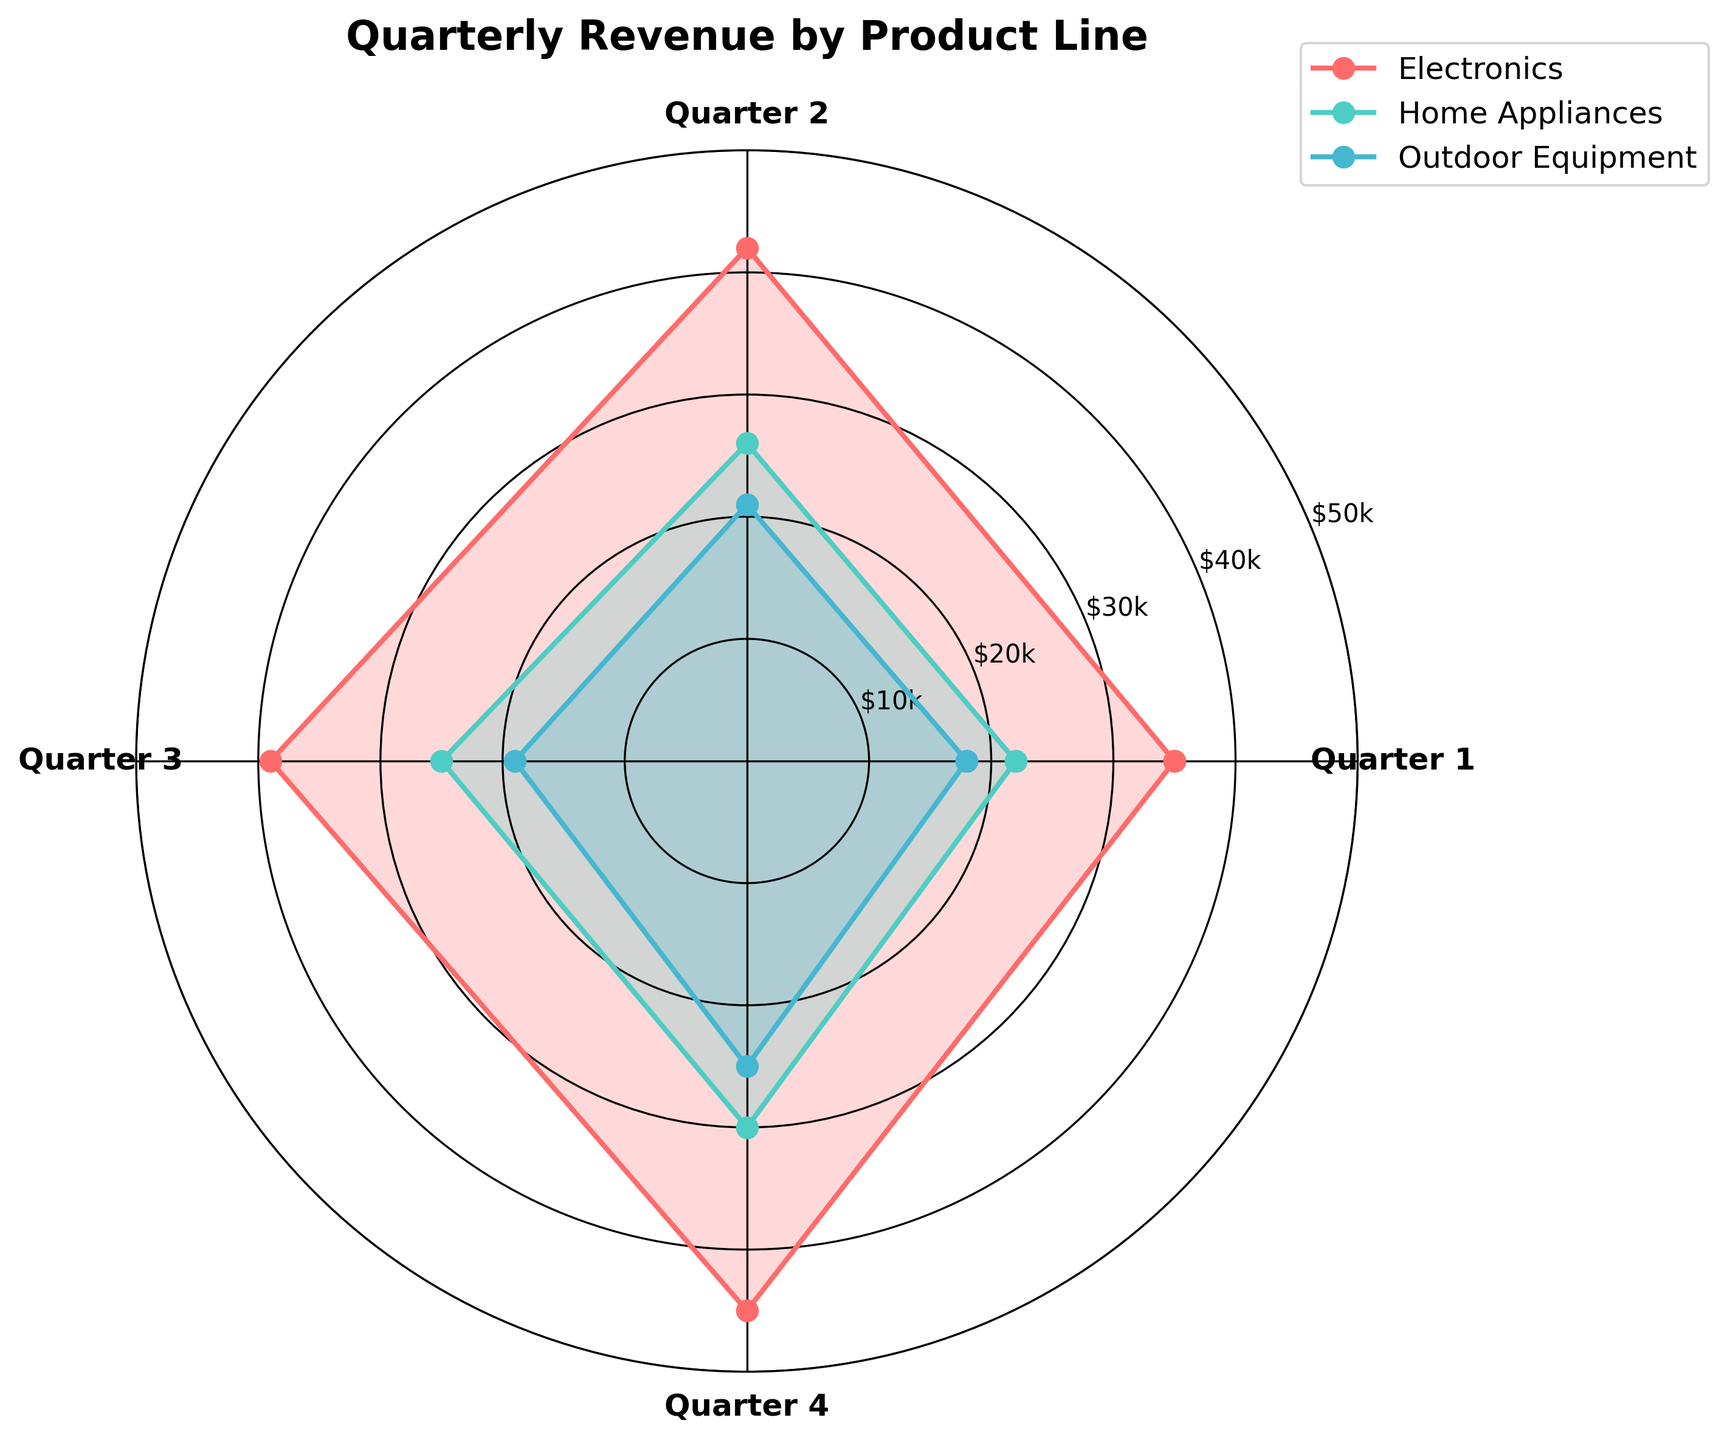What is the title of the chart? The title is displayed at the top of the chart.
Answer: Quarterly Revenue by Product Line Which product line has the highest revenue in Quarter 4? Look at the plot lines and areas filled in for Quarter 4 and identify the highest. Electronics has the highest fill and peak in Quarter 4.
Answer: Electronics What is the overall trend in revenue for Home Appliances over the four quarters? Observe the filled area and plot line for the Home Appliances product line. The filled area gradually increases, indicating an upward trend.
Answer: Increasing How much revenue did the Outdoor Equipment category generate in Quarter 1? Locate the segment of the rose chart for Quarter 1. The radius for Outdoor Equipment corresponds to the revenue, which is $18,000.
Answer: $18,000 Does any product line surpass $40,000 in any quarter? Identify segments in the chart with radius extending beyond $40,000. The Electronics line surpasses $40,000 in both Quarter 2 and Quarter 4.
Answer: Yes Which quarter shows the least revenue for Electronics? Compare the filled areas and plot points of the Electronics line across quarters. Quarters 2 has a smaller radius compared to other quarters.
Answer: Quarter 1 Calculate the average quarterly revenue for Home Appliances. Sum of Home Appliances revenues across four quarters is $22,000 + $26,000 + $25,000 + $30,000 = $103,000. The average is $103,000 / 4 = $25,750.
Answer: $25,750 Compare the revenue difference between Electronics and Outdoor Equipment in Quarter 3. Revenue for Electronics in Quarter 3 is $39,000 and for Outdoor Equipment is $19,000. The difference is $39,000 - $19,000 = $20,000.
Answer: $20,000 Which product line exhibits the most consistent revenue across all quarters? Look at the consistency in the areas and plot lines. Home Appliances shows a steady and small increase across all quarters compared to fluctuations in Electronics and Outdoor Equipment.
Answer: Home Appliances 